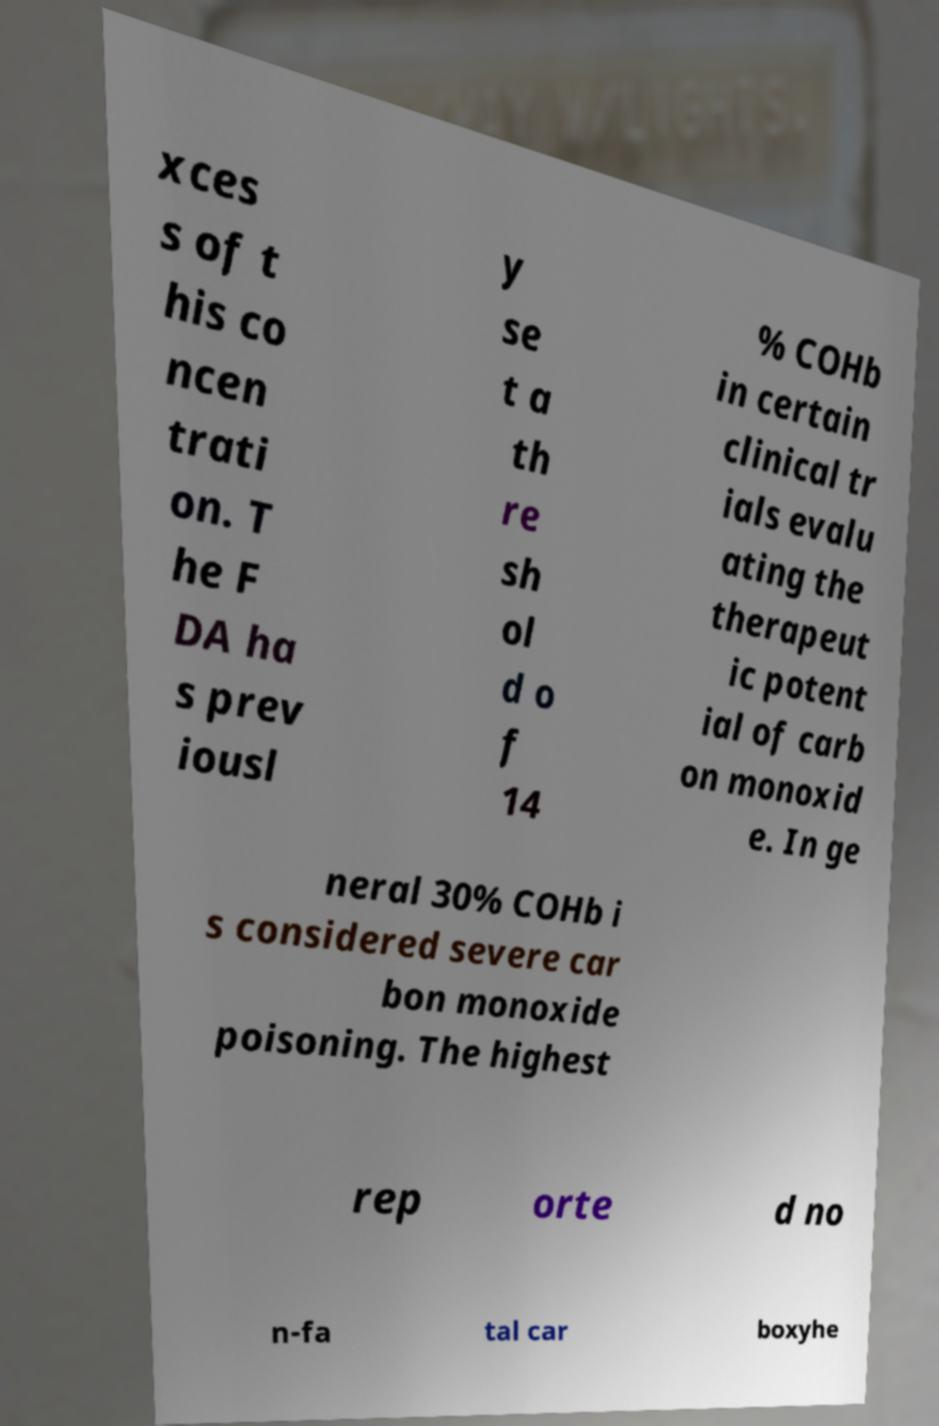What messages or text are displayed in this image? I need them in a readable, typed format. xces s of t his co ncen trati on. T he F DA ha s prev iousl y se t a th re sh ol d o f 14 % COHb in certain clinical tr ials evalu ating the therapeut ic potent ial of carb on monoxid e. In ge neral 30% COHb i s considered severe car bon monoxide poisoning. The highest rep orte d no n-fa tal car boxyhe 